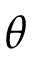Convert formula to latex. <formula><loc_0><loc_0><loc_500><loc_500>\theta</formula> 